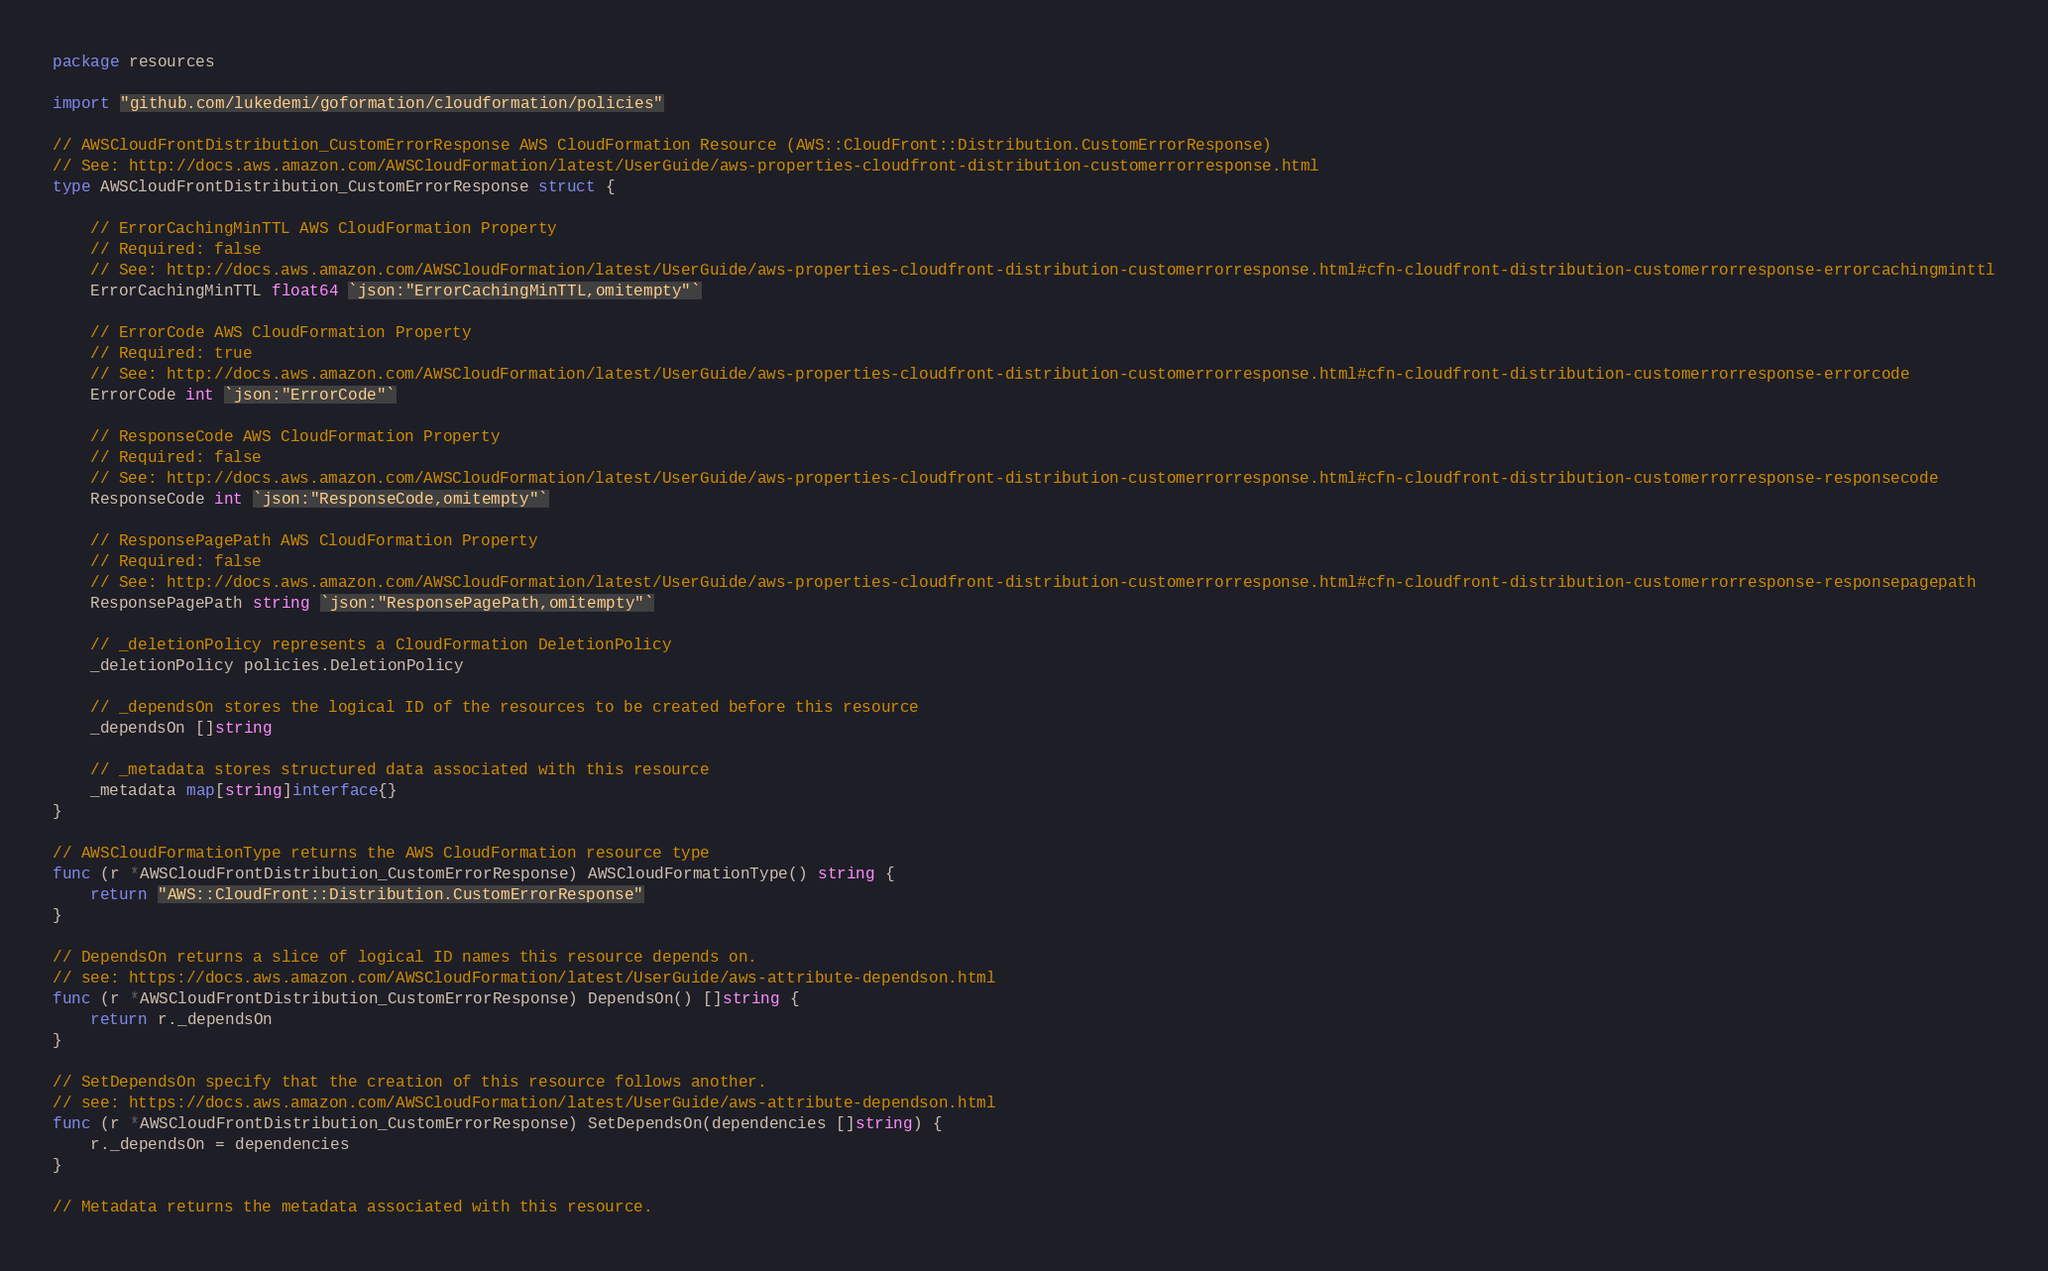Convert code to text. <code><loc_0><loc_0><loc_500><loc_500><_Go_>package resources

import "github.com/lukedemi/goformation/cloudformation/policies"

// AWSCloudFrontDistribution_CustomErrorResponse AWS CloudFormation Resource (AWS::CloudFront::Distribution.CustomErrorResponse)
// See: http://docs.aws.amazon.com/AWSCloudFormation/latest/UserGuide/aws-properties-cloudfront-distribution-customerrorresponse.html
type AWSCloudFrontDistribution_CustomErrorResponse struct {

	// ErrorCachingMinTTL AWS CloudFormation Property
	// Required: false
	// See: http://docs.aws.amazon.com/AWSCloudFormation/latest/UserGuide/aws-properties-cloudfront-distribution-customerrorresponse.html#cfn-cloudfront-distribution-customerrorresponse-errorcachingminttl
	ErrorCachingMinTTL float64 `json:"ErrorCachingMinTTL,omitempty"`

	// ErrorCode AWS CloudFormation Property
	// Required: true
	// See: http://docs.aws.amazon.com/AWSCloudFormation/latest/UserGuide/aws-properties-cloudfront-distribution-customerrorresponse.html#cfn-cloudfront-distribution-customerrorresponse-errorcode
	ErrorCode int `json:"ErrorCode"`

	// ResponseCode AWS CloudFormation Property
	// Required: false
	// See: http://docs.aws.amazon.com/AWSCloudFormation/latest/UserGuide/aws-properties-cloudfront-distribution-customerrorresponse.html#cfn-cloudfront-distribution-customerrorresponse-responsecode
	ResponseCode int `json:"ResponseCode,omitempty"`

	// ResponsePagePath AWS CloudFormation Property
	// Required: false
	// See: http://docs.aws.amazon.com/AWSCloudFormation/latest/UserGuide/aws-properties-cloudfront-distribution-customerrorresponse.html#cfn-cloudfront-distribution-customerrorresponse-responsepagepath
	ResponsePagePath string `json:"ResponsePagePath,omitempty"`

	// _deletionPolicy represents a CloudFormation DeletionPolicy
	_deletionPolicy policies.DeletionPolicy

	// _dependsOn stores the logical ID of the resources to be created before this resource
	_dependsOn []string

	// _metadata stores structured data associated with this resource
	_metadata map[string]interface{}
}

// AWSCloudFormationType returns the AWS CloudFormation resource type
func (r *AWSCloudFrontDistribution_CustomErrorResponse) AWSCloudFormationType() string {
	return "AWS::CloudFront::Distribution.CustomErrorResponse"
}

// DependsOn returns a slice of logical ID names this resource depends on.
// see: https://docs.aws.amazon.com/AWSCloudFormation/latest/UserGuide/aws-attribute-dependson.html
func (r *AWSCloudFrontDistribution_CustomErrorResponse) DependsOn() []string {
	return r._dependsOn
}

// SetDependsOn specify that the creation of this resource follows another.
// see: https://docs.aws.amazon.com/AWSCloudFormation/latest/UserGuide/aws-attribute-dependson.html
func (r *AWSCloudFrontDistribution_CustomErrorResponse) SetDependsOn(dependencies []string) {
	r._dependsOn = dependencies
}

// Metadata returns the metadata associated with this resource.</code> 